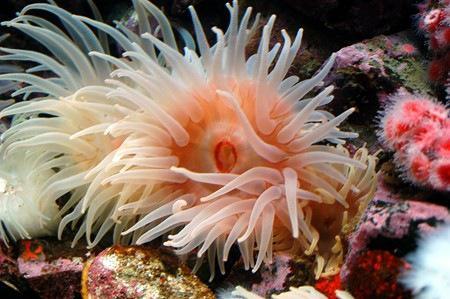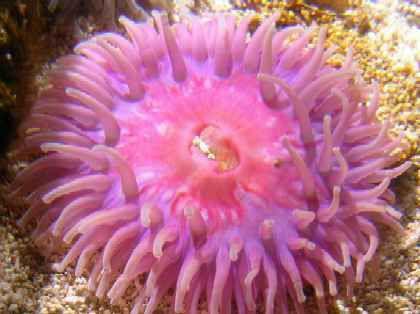The first image is the image on the left, the second image is the image on the right. For the images displayed, is the sentence "In at least one image, there are at least different two types of coral with the base color pink or white." factually correct? Answer yes or no. Yes. The first image is the image on the left, the second image is the image on the right. Given the left and right images, does the statement "Looking down from the top angle, into the colorful anemone pictured in the image on the right, reveals a central, mouth-like opening, surrounded by tentacles." hold true? Answer yes or no. Yes. 